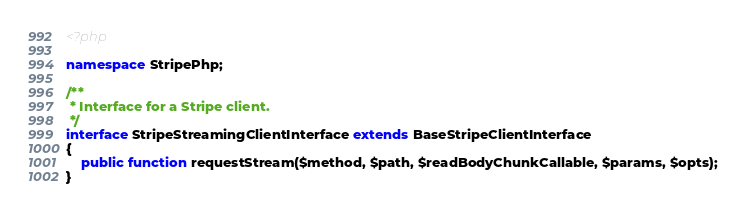<code> <loc_0><loc_0><loc_500><loc_500><_PHP_><?php

namespace StripePhp;

/**
 * Interface for a Stripe client.
 */
interface StripeStreamingClientInterface extends BaseStripeClientInterface
{
    public function requestStream($method, $path, $readBodyChunkCallable, $params, $opts);
}
</code> 